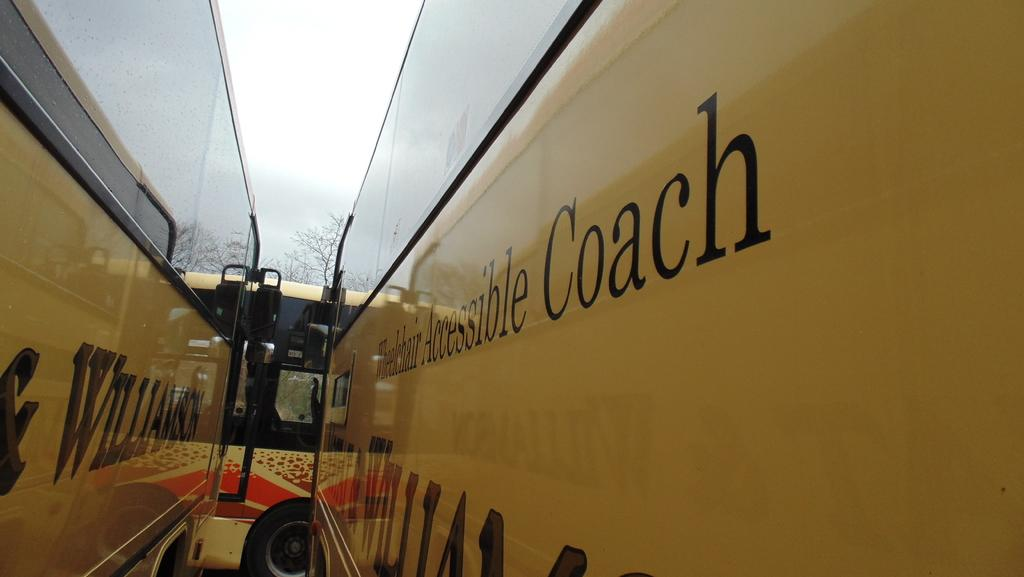What type of vehicles are present in the image? There are buses in the image. What can be seen at the top of the image? The sky is visible at the top of the image. What is the plot of the story being written on the bus in the image? There is no story being written on the bus in the image; it only shows buses and the sky. What type of game is being played on the bus in the image? There is no game being played on the bus in the image; it only shows buses and the sky. 